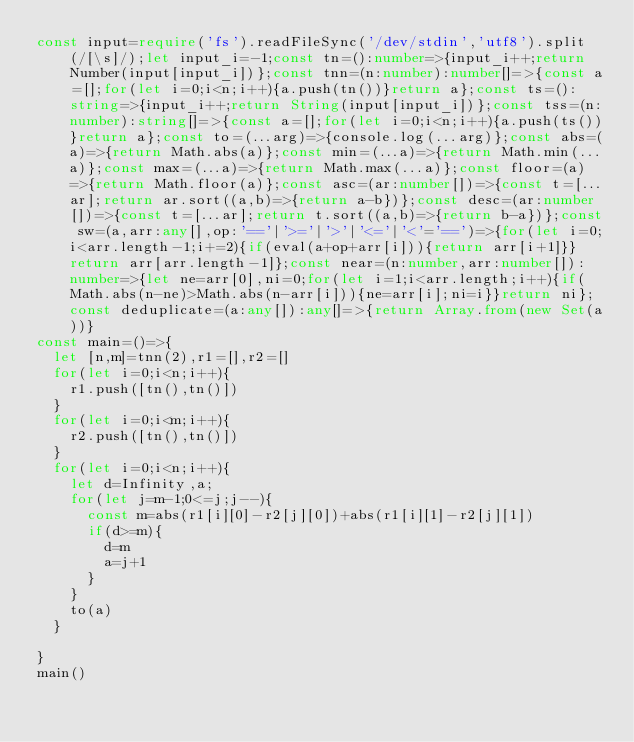Convert code to text. <code><loc_0><loc_0><loc_500><loc_500><_TypeScript_>const input=require('fs').readFileSync('/dev/stdin','utf8').split(/[\s]/);let input_i=-1;const tn=():number=>{input_i++;return Number(input[input_i])};const tnn=(n:number):number[]=>{const a=[];for(let i=0;i<n;i++){a.push(tn())}return a};const ts=():string=>{input_i++;return String(input[input_i])};const tss=(n:number):string[]=>{const a=[];for(let i=0;i<n;i++){a.push(ts())}return a};const to=(...arg)=>{console.log(...arg)};const abs=(a)=>{return Math.abs(a)};const min=(...a)=>{return Math.min(...a)};const max=(...a)=>{return Math.max(...a)};const floor=(a)=>{return Math.floor(a)};const asc=(ar:number[])=>{const t=[...ar];return ar.sort((a,b)=>{return a-b})};const desc=(ar:number[])=>{const t=[...ar];return t.sort((a,b)=>{return b-a})};const sw=(a,arr:any[],op:'=='|'>='|'>'|'<='|'<'='==')=>{for(let i=0;i<arr.length-1;i+=2){if(eval(a+op+arr[i])){return arr[i+1]}}return arr[arr.length-1]};const near=(n:number,arr:number[]):number=>{let ne=arr[0],ni=0;for(let i=1;i<arr.length;i++){if(Math.abs(n-ne)>Math.abs(n-arr[i])){ne=arr[i];ni=i}}return ni};const deduplicate=(a:any[]):any[]=>{return Array.from(new Set(a))}
const main=()=>{
  let [n,m]=tnn(2),r1=[],r2=[]
  for(let i=0;i<n;i++){
    r1.push([tn(),tn()])
  }
  for(let i=0;i<m;i++){
    r2.push([tn(),tn()])
  }
  for(let i=0;i<n;i++){
    let d=Infinity,a;
    for(let j=m-1;0<=j;j--){
      const m=abs(r1[i][0]-r2[j][0])+abs(r1[i][1]-r2[j][1])
      if(d>=m){
        d=m
        a=j+1
      }
    }
    to(a)
  }

}
main()</code> 